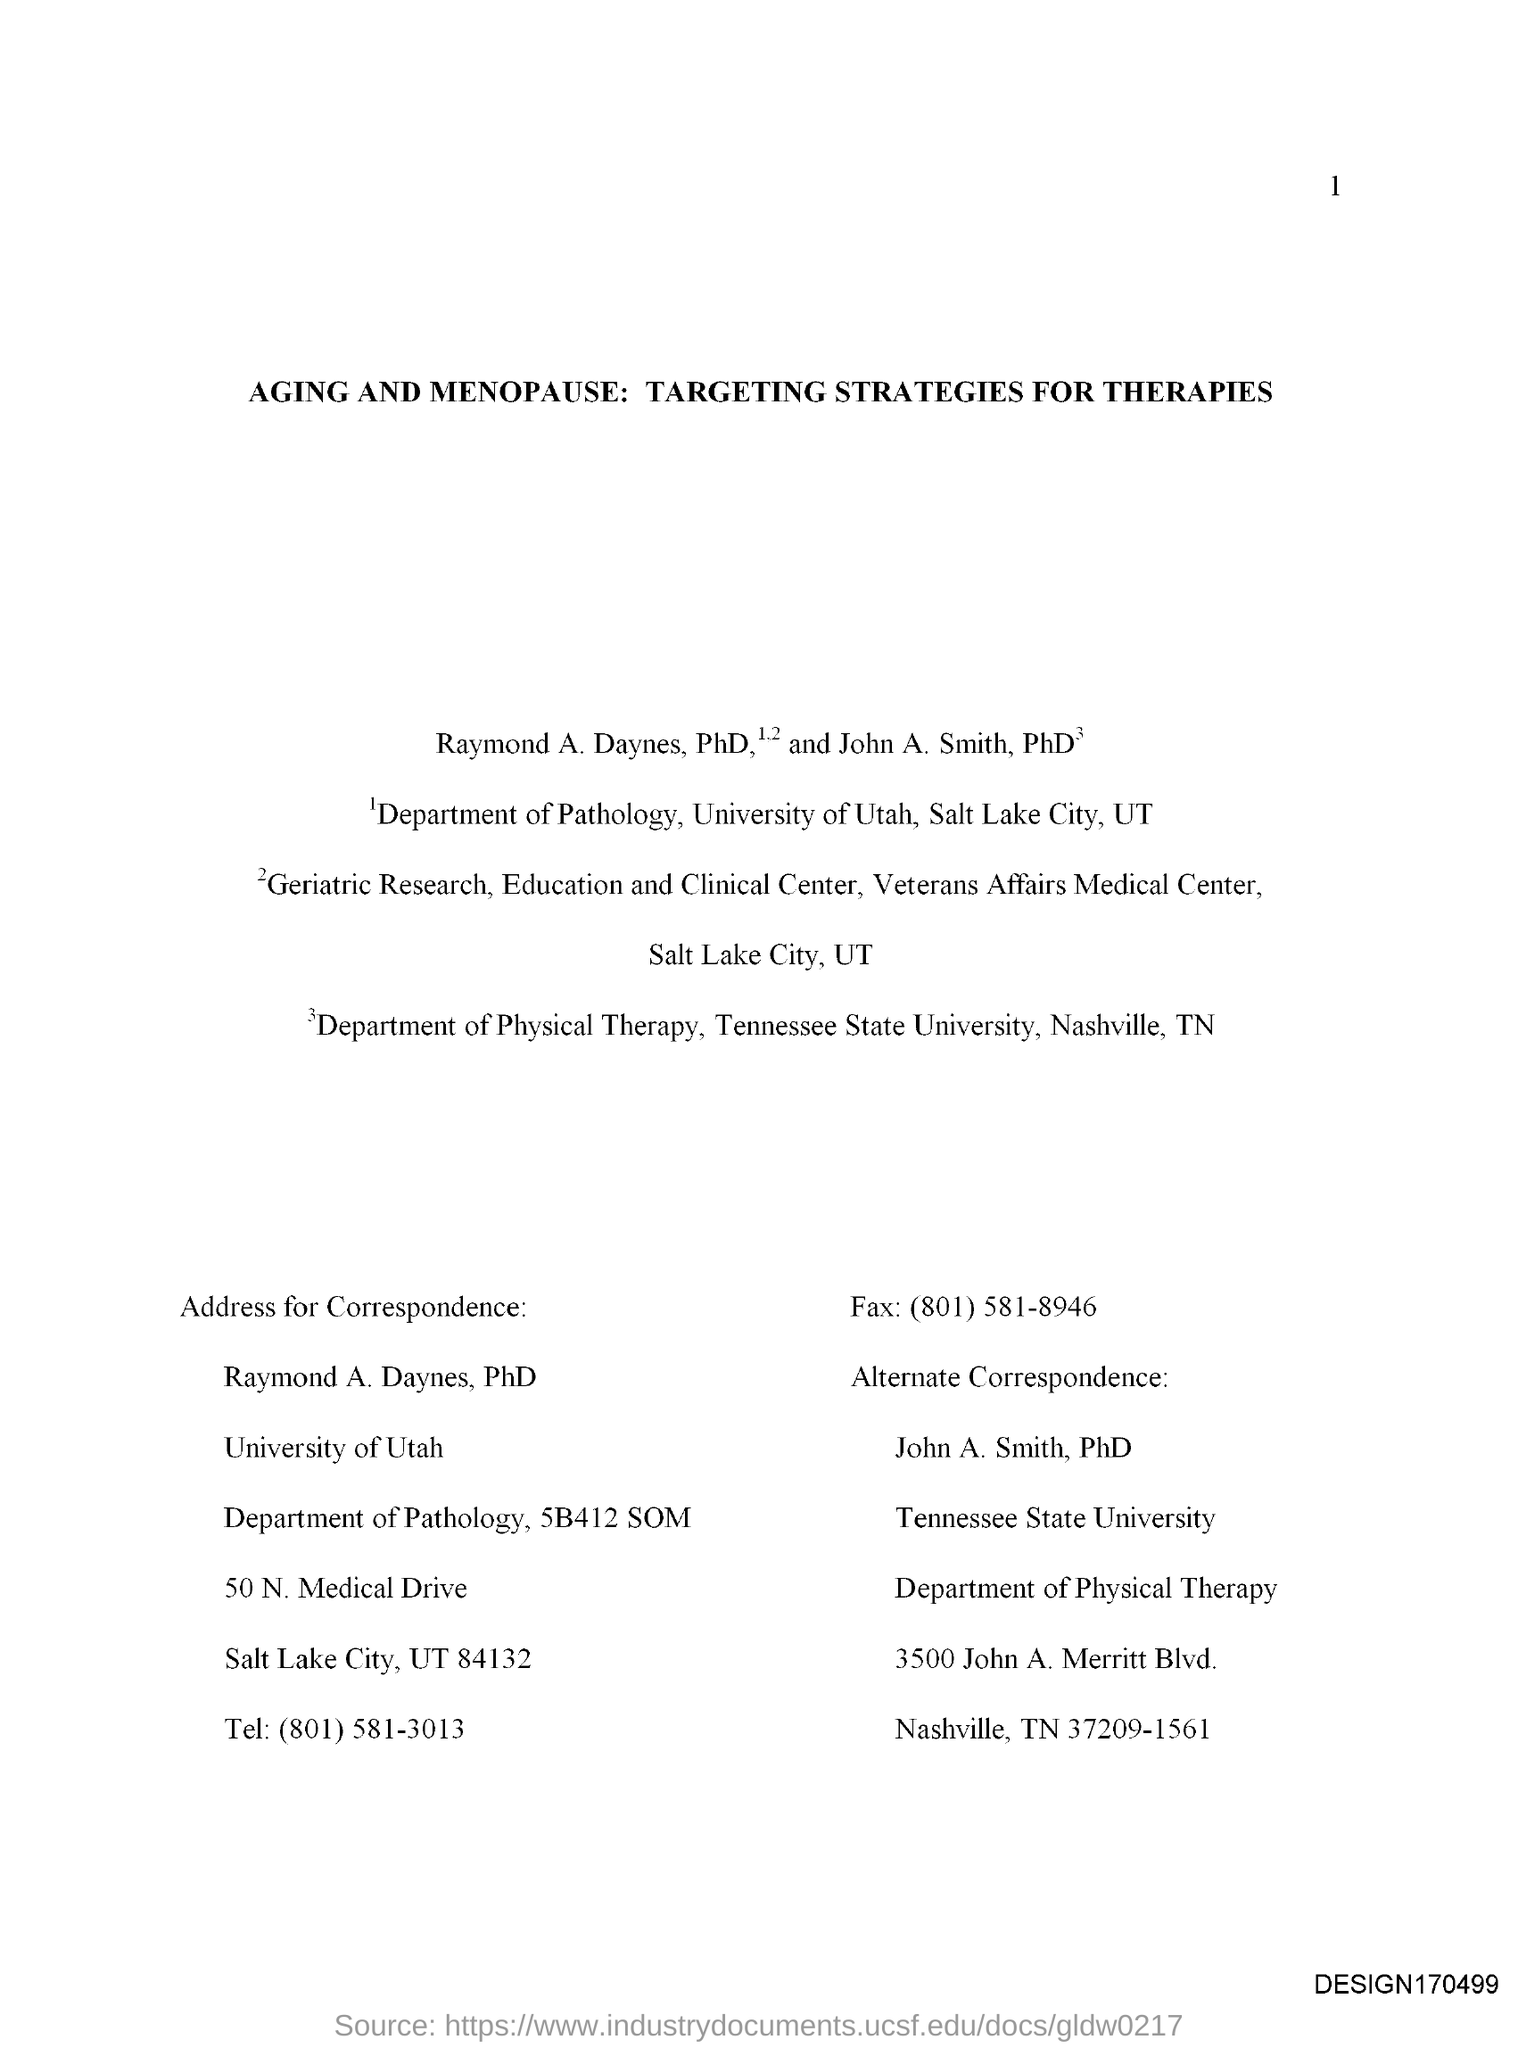What is the title of the document?
Your answer should be compact. Aging and Menopause: Targeting strategies for Therapies. 